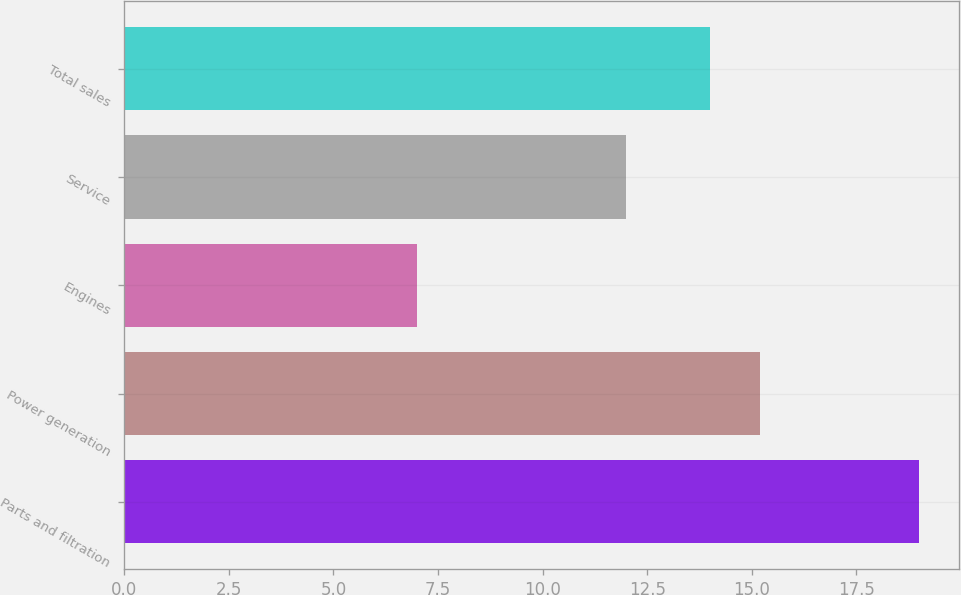Convert chart to OTSL. <chart><loc_0><loc_0><loc_500><loc_500><bar_chart><fcel>Parts and filtration<fcel>Power generation<fcel>Engines<fcel>Service<fcel>Total sales<nl><fcel>19<fcel>15.2<fcel>7<fcel>12<fcel>14<nl></chart> 